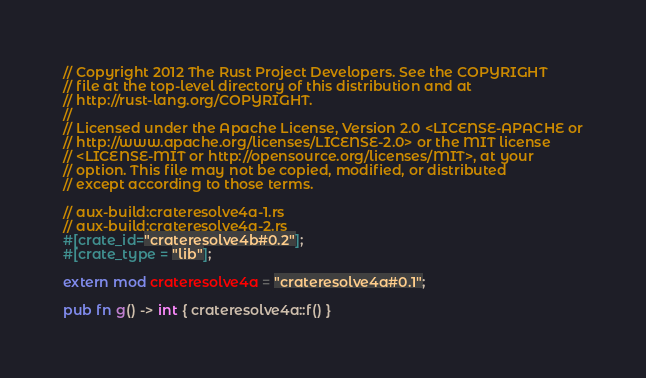Convert code to text. <code><loc_0><loc_0><loc_500><loc_500><_Rust_>// Copyright 2012 The Rust Project Developers. See the COPYRIGHT
// file at the top-level directory of this distribution and at
// http://rust-lang.org/COPYRIGHT.
//
// Licensed under the Apache License, Version 2.0 <LICENSE-APACHE or
// http://www.apache.org/licenses/LICENSE-2.0> or the MIT license
// <LICENSE-MIT or http://opensource.org/licenses/MIT>, at your
// option. This file may not be copied, modified, or distributed
// except according to those terms.

// aux-build:crateresolve4a-1.rs
// aux-build:crateresolve4a-2.rs
#[crate_id="crateresolve4b#0.2"];
#[crate_type = "lib"];

extern mod crateresolve4a = "crateresolve4a#0.1";

pub fn g() -> int { crateresolve4a::f() }
</code> 